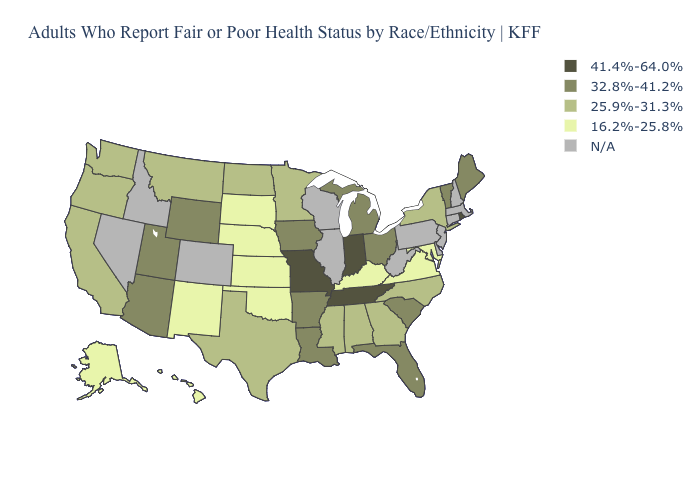Which states hav the highest value in the Northeast?
Quick response, please. Rhode Island. Name the states that have a value in the range 25.9%-31.3%?
Short answer required. Alabama, California, Georgia, Minnesota, Mississippi, Montana, New York, North Carolina, North Dakota, Oregon, Texas, Washington. Name the states that have a value in the range 41.4%-64.0%?
Be succinct. Indiana, Missouri, Rhode Island, Tennessee. Among the states that border West Virginia , which have the lowest value?
Keep it brief. Kentucky, Maryland, Virginia. What is the lowest value in the USA?
Keep it brief. 16.2%-25.8%. What is the value of Illinois?
Give a very brief answer. N/A. Name the states that have a value in the range 41.4%-64.0%?
Give a very brief answer. Indiana, Missouri, Rhode Island, Tennessee. Name the states that have a value in the range N/A?
Quick response, please. Colorado, Connecticut, Delaware, Idaho, Illinois, Massachusetts, Nevada, New Hampshire, New Jersey, Pennsylvania, West Virginia, Wisconsin. Name the states that have a value in the range 16.2%-25.8%?
Answer briefly. Alaska, Hawaii, Kansas, Kentucky, Maryland, Nebraska, New Mexico, Oklahoma, South Dakota, Virginia. Name the states that have a value in the range 32.8%-41.2%?
Give a very brief answer. Arizona, Arkansas, Florida, Iowa, Louisiana, Maine, Michigan, Ohio, South Carolina, Utah, Vermont, Wyoming. What is the highest value in the West ?
Answer briefly. 32.8%-41.2%. What is the value of Michigan?
Write a very short answer. 32.8%-41.2%. Which states hav the highest value in the West?
Quick response, please. Arizona, Utah, Wyoming. Name the states that have a value in the range 16.2%-25.8%?
Give a very brief answer. Alaska, Hawaii, Kansas, Kentucky, Maryland, Nebraska, New Mexico, Oklahoma, South Dakota, Virginia. Name the states that have a value in the range 25.9%-31.3%?
Give a very brief answer. Alabama, California, Georgia, Minnesota, Mississippi, Montana, New York, North Carolina, North Dakota, Oregon, Texas, Washington. 